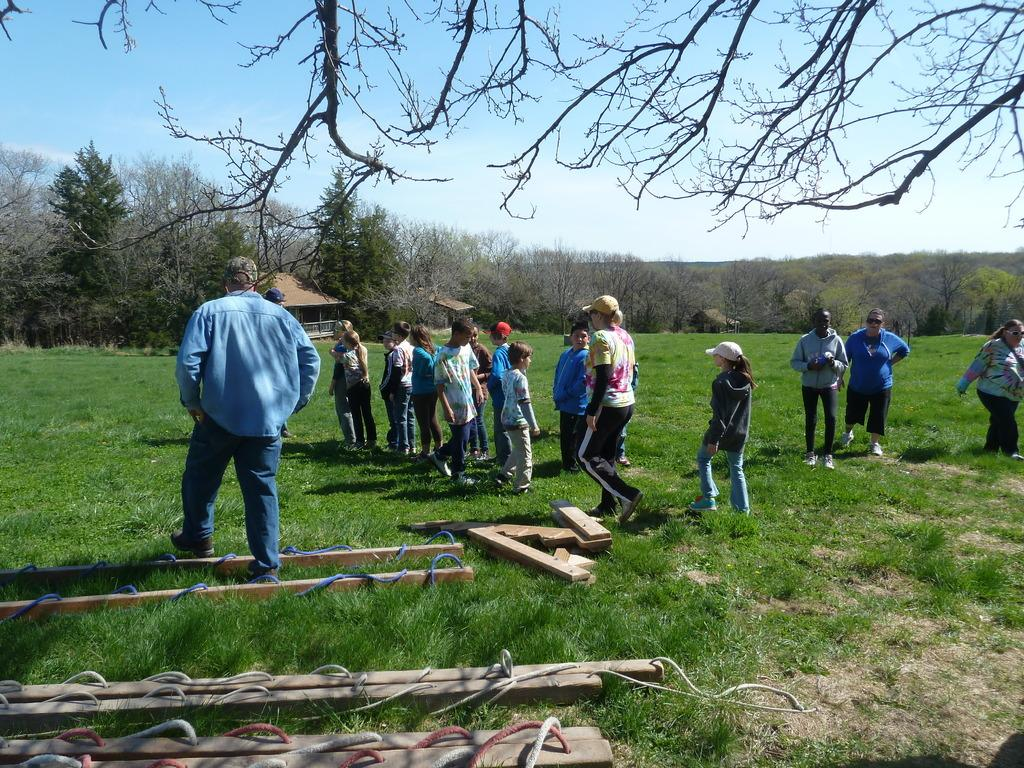What can be seen in the image? There are kids and people standing in the image. What is on the floor in the image? There is grass on the floor in the image. What is visible in the background of the image? There is a building and trees in the backdrop of the image. What is the condition of the sky in the image? The sky is clear in the image. What type of property is being discussed in the image? There is no discussion of property in the image; it primarily features kids and people standing on grass. Is there any rain visible in the image? No, there is no rain visible in the image; the sky is clear. 